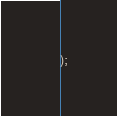<code> <loc_0><loc_0><loc_500><loc_500><_SQL_>);

</code> 